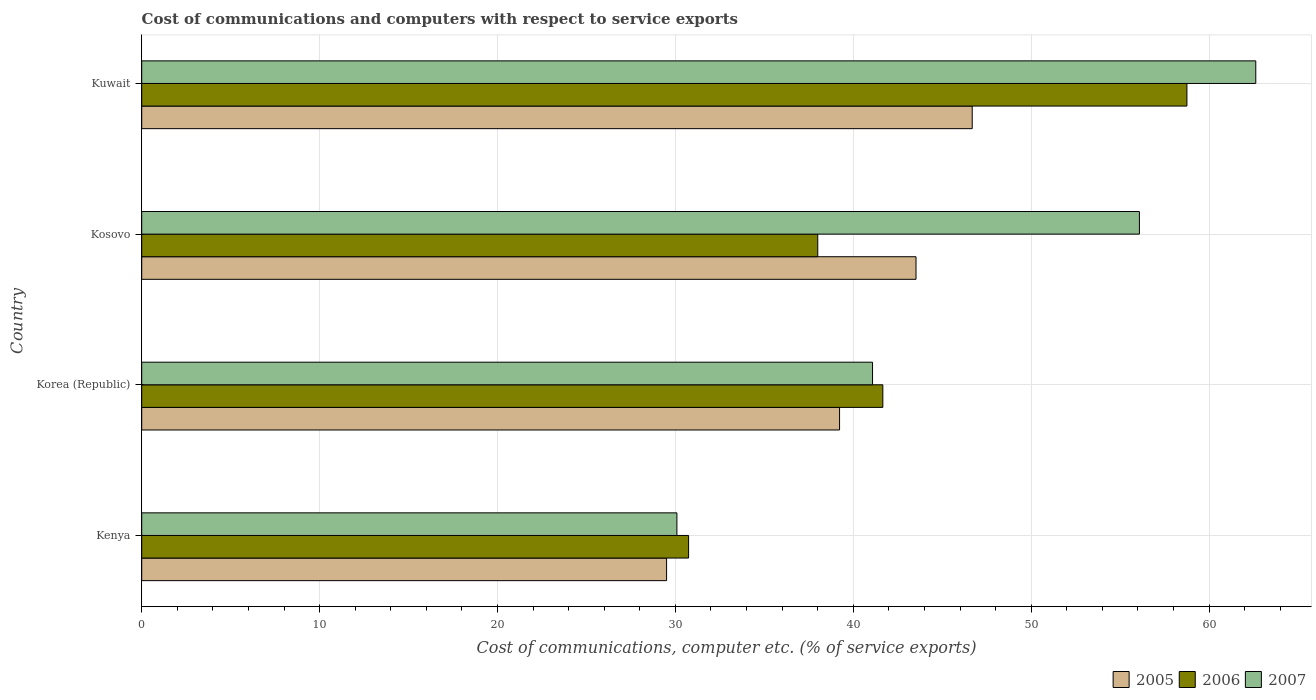How many different coloured bars are there?
Your answer should be very brief. 3. What is the label of the 4th group of bars from the top?
Offer a very short reply. Kenya. In how many cases, is the number of bars for a given country not equal to the number of legend labels?
Make the answer very short. 0. What is the cost of communications and computers in 2007 in Korea (Republic)?
Your answer should be very brief. 41.08. Across all countries, what is the maximum cost of communications and computers in 2005?
Make the answer very short. 46.69. Across all countries, what is the minimum cost of communications and computers in 2006?
Make the answer very short. 30.74. In which country was the cost of communications and computers in 2006 maximum?
Your response must be concise. Kuwait. In which country was the cost of communications and computers in 2005 minimum?
Your response must be concise. Kenya. What is the total cost of communications and computers in 2005 in the graph?
Give a very brief answer. 158.95. What is the difference between the cost of communications and computers in 2006 in Kenya and that in Kosovo?
Offer a terse response. -7.26. What is the difference between the cost of communications and computers in 2006 in Kosovo and the cost of communications and computers in 2007 in Korea (Republic)?
Provide a short and direct response. -3.08. What is the average cost of communications and computers in 2007 per country?
Your response must be concise. 47.47. What is the difference between the cost of communications and computers in 2006 and cost of communications and computers in 2005 in Korea (Republic)?
Ensure brevity in your answer.  2.43. What is the ratio of the cost of communications and computers in 2005 in Korea (Republic) to that in Kosovo?
Offer a very short reply. 0.9. What is the difference between the highest and the second highest cost of communications and computers in 2006?
Offer a terse response. 17.09. What is the difference between the highest and the lowest cost of communications and computers in 2006?
Your response must be concise. 28.01. In how many countries, is the cost of communications and computers in 2007 greater than the average cost of communications and computers in 2007 taken over all countries?
Your response must be concise. 2. Is the sum of the cost of communications and computers in 2005 in Kenya and Kosovo greater than the maximum cost of communications and computers in 2007 across all countries?
Make the answer very short. Yes. What does the 3rd bar from the bottom in Kenya represents?
Ensure brevity in your answer.  2007. How many bars are there?
Make the answer very short. 12. How many countries are there in the graph?
Keep it short and to the point. 4. Does the graph contain grids?
Provide a succinct answer. Yes. How are the legend labels stacked?
Make the answer very short. Horizontal. What is the title of the graph?
Your response must be concise. Cost of communications and computers with respect to service exports. Does "1995" appear as one of the legend labels in the graph?
Keep it short and to the point. No. What is the label or title of the X-axis?
Give a very brief answer. Cost of communications, computer etc. (% of service exports). What is the Cost of communications, computer etc. (% of service exports) of 2005 in Kenya?
Offer a very short reply. 29.5. What is the Cost of communications, computer etc. (% of service exports) in 2006 in Kenya?
Your response must be concise. 30.74. What is the Cost of communications, computer etc. (% of service exports) of 2007 in Kenya?
Provide a short and direct response. 30.09. What is the Cost of communications, computer etc. (% of service exports) of 2005 in Korea (Republic)?
Make the answer very short. 39.23. What is the Cost of communications, computer etc. (% of service exports) in 2006 in Korea (Republic)?
Your answer should be very brief. 41.66. What is the Cost of communications, computer etc. (% of service exports) in 2007 in Korea (Republic)?
Your answer should be compact. 41.08. What is the Cost of communications, computer etc. (% of service exports) in 2005 in Kosovo?
Offer a very short reply. 43.53. What is the Cost of communications, computer etc. (% of service exports) of 2006 in Kosovo?
Provide a short and direct response. 38. What is the Cost of communications, computer etc. (% of service exports) of 2007 in Kosovo?
Provide a succinct answer. 56.09. What is the Cost of communications, computer etc. (% of service exports) in 2005 in Kuwait?
Your answer should be compact. 46.69. What is the Cost of communications, computer etc. (% of service exports) in 2006 in Kuwait?
Give a very brief answer. 58.76. What is the Cost of communications, computer etc. (% of service exports) in 2007 in Kuwait?
Your answer should be compact. 62.63. Across all countries, what is the maximum Cost of communications, computer etc. (% of service exports) in 2005?
Ensure brevity in your answer.  46.69. Across all countries, what is the maximum Cost of communications, computer etc. (% of service exports) of 2006?
Provide a short and direct response. 58.76. Across all countries, what is the maximum Cost of communications, computer etc. (% of service exports) in 2007?
Offer a very short reply. 62.63. Across all countries, what is the minimum Cost of communications, computer etc. (% of service exports) of 2005?
Keep it short and to the point. 29.5. Across all countries, what is the minimum Cost of communications, computer etc. (% of service exports) of 2006?
Provide a succinct answer. 30.74. Across all countries, what is the minimum Cost of communications, computer etc. (% of service exports) of 2007?
Offer a terse response. 30.09. What is the total Cost of communications, computer etc. (% of service exports) of 2005 in the graph?
Offer a terse response. 158.95. What is the total Cost of communications, computer etc. (% of service exports) in 2006 in the graph?
Your response must be concise. 169.16. What is the total Cost of communications, computer etc. (% of service exports) of 2007 in the graph?
Your response must be concise. 189.88. What is the difference between the Cost of communications, computer etc. (% of service exports) in 2005 in Kenya and that in Korea (Republic)?
Provide a succinct answer. -9.72. What is the difference between the Cost of communications, computer etc. (% of service exports) in 2006 in Kenya and that in Korea (Republic)?
Offer a very short reply. -10.92. What is the difference between the Cost of communications, computer etc. (% of service exports) of 2007 in Kenya and that in Korea (Republic)?
Give a very brief answer. -11. What is the difference between the Cost of communications, computer etc. (% of service exports) of 2005 in Kenya and that in Kosovo?
Offer a terse response. -14.02. What is the difference between the Cost of communications, computer etc. (% of service exports) in 2006 in Kenya and that in Kosovo?
Keep it short and to the point. -7.26. What is the difference between the Cost of communications, computer etc. (% of service exports) in 2007 in Kenya and that in Kosovo?
Your response must be concise. -26. What is the difference between the Cost of communications, computer etc. (% of service exports) in 2005 in Kenya and that in Kuwait?
Keep it short and to the point. -17.18. What is the difference between the Cost of communications, computer etc. (% of service exports) in 2006 in Kenya and that in Kuwait?
Ensure brevity in your answer.  -28.01. What is the difference between the Cost of communications, computer etc. (% of service exports) in 2007 in Kenya and that in Kuwait?
Provide a succinct answer. -32.54. What is the difference between the Cost of communications, computer etc. (% of service exports) of 2005 in Korea (Republic) and that in Kosovo?
Offer a very short reply. -4.3. What is the difference between the Cost of communications, computer etc. (% of service exports) in 2006 in Korea (Republic) and that in Kosovo?
Your response must be concise. 3.66. What is the difference between the Cost of communications, computer etc. (% of service exports) in 2007 in Korea (Republic) and that in Kosovo?
Offer a very short reply. -15. What is the difference between the Cost of communications, computer etc. (% of service exports) of 2005 in Korea (Republic) and that in Kuwait?
Provide a succinct answer. -7.46. What is the difference between the Cost of communications, computer etc. (% of service exports) of 2006 in Korea (Republic) and that in Kuwait?
Make the answer very short. -17.09. What is the difference between the Cost of communications, computer etc. (% of service exports) of 2007 in Korea (Republic) and that in Kuwait?
Offer a terse response. -21.54. What is the difference between the Cost of communications, computer etc. (% of service exports) in 2005 in Kosovo and that in Kuwait?
Offer a very short reply. -3.16. What is the difference between the Cost of communications, computer etc. (% of service exports) of 2006 in Kosovo and that in Kuwait?
Offer a very short reply. -20.75. What is the difference between the Cost of communications, computer etc. (% of service exports) in 2007 in Kosovo and that in Kuwait?
Your answer should be very brief. -6.54. What is the difference between the Cost of communications, computer etc. (% of service exports) in 2005 in Kenya and the Cost of communications, computer etc. (% of service exports) in 2006 in Korea (Republic)?
Your answer should be compact. -12.16. What is the difference between the Cost of communications, computer etc. (% of service exports) of 2005 in Kenya and the Cost of communications, computer etc. (% of service exports) of 2007 in Korea (Republic)?
Offer a terse response. -11.58. What is the difference between the Cost of communications, computer etc. (% of service exports) of 2006 in Kenya and the Cost of communications, computer etc. (% of service exports) of 2007 in Korea (Republic)?
Keep it short and to the point. -10.34. What is the difference between the Cost of communications, computer etc. (% of service exports) of 2005 in Kenya and the Cost of communications, computer etc. (% of service exports) of 2006 in Kosovo?
Provide a short and direct response. -8.5. What is the difference between the Cost of communications, computer etc. (% of service exports) of 2005 in Kenya and the Cost of communications, computer etc. (% of service exports) of 2007 in Kosovo?
Make the answer very short. -26.58. What is the difference between the Cost of communications, computer etc. (% of service exports) in 2006 in Kenya and the Cost of communications, computer etc. (% of service exports) in 2007 in Kosovo?
Keep it short and to the point. -25.34. What is the difference between the Cost of communications, computer etc. (% of service exports) in 2005 in Kenya and the Cost of communications, computer etc. (% of service exports) in 2006 in Kuwait?
Provide a short and direct response. -29.25. What is the difference between the Cost of communications, computer etc. (% of service exports) of 2005 in Kenya and the Cost of communications, computer etc. (% of service exports) of 2007 in Kuwait?
Provide a succinct answer. -33.12. What is the difference between the Cost of communications, computer etc. (% of service exports) of 2006 in Kenya and the Cost of communications, computer etc. (% of service exports) of 2007 in Kuwait?
Your answer should be compact. -31.88. What is the difference between the Cost of communications, computer etc. (% of service exports) in 2005 in Korea (Republic) and the Cost of communications, computer etc. (% of service exports) in 2006 in Kosovo?
Your answer should be compact. 1.23. What is the difference between the Cost of communications, computer etc. (% of service exports) in 2005 in Korea (Republic) and the Cost of communications, computer etc. (% of service exports) in 2007 in Kosovo?
Your answer should be very brief. -16.86. What is the difference between the Cost of communications, computer etc. (% of service exports) of 2006 in Korea (Republic) and the Cost of communications, computer etc. (% of service exports) of 2007 in Kosovo?
Offer a terse response. -14.42. What is the difference between the Cost of communications, computer etc. (% of service exports) in 2005 in Korea (Republic) and the Cost of communications, computer etc. (% of service exports) in 2006 in Kuwait?
Make the answer very short. -19.53. What is the difference between the Cost of communications, computer etc. (% of service exports) in 2005 in Korea (Republic) and the Cost of communications, computer etc. (% of service exports) in 2007 in Kuwait?
Your answer should be very brief. -23.4. What is the difference between the Cost of communications, computer etc. (% of service exports) in 2006 in Korea (Republic) and the Cost of communications, computer etc. (% of service exports) in 2007 in Kuwait?
Make the answer very short. -20.96. What is the difference between the Cost of communications, computer etc. (% of service exports) of 2005 in Kosovo and the Cost of communications, computer etc. (% of service exports) of 2006 in Kuwait?
Keep it short and to the point. -15.23. What is the difference between the Cost of communications, computer etc. (% of service exports) of 2005 in Kosovo and the Cost of communications, computer etc. (% of service exports) of 2007 in Kuwait?
Give a very brief answer. -19.1. What is the difference between the Cost of communications, computer etc. (% of service exports) of 2006 in Kosovo and the Cost of communications, computer etc. (% of service exports) of 2007 in Kuwait?
Your answer should be compact. -24.62. What is the average Cost of communications, computer etc. (% of service exports) in 2005 per country?
Provide a short and direct response. 39.74. What is the average Cost of communications, computer etc. (% of service exports) of 2006 per country?
Your answer should be very brief. 42.29. What is the average Cost of communications, computer etc. (% of service exports) of 2007 per country?
Provide a succinct answer. 47.47. What is the difference between the Cost of communications, computer etc. (% of service exports) of 2005 and Cost of communications, computer etc. (% of service exports) of 2006 in Kenya?
Offer a terse response. -1.24. What is the difference between the Cost of communications, computer etc. (% of service exports) of 2005 and Cost of communications, computer etc. (% of service exports) of 2007 in Kenya?
Provide a succinct answer. -0.58. What is the difference between the Cost of communications, computer etc. (% of service exports) of 2006 and Cost of communications, computer etc. (% of service exports) of 2007 in Kenya?
Offer a very short reply. 0.66. What is the difference between the Cost of communications, computer etc. (% of service exports) in 2005 and Cost of communications, computer etc. (% of service exports) in 2006 in Korea (Republic)?
Ensure brevity in your answer.  -2.43. What is the difference between the Cost of communications, computer etc. (% of service exports) in 2005 and Cost of communications, computer etc. (% of service exports) in 2007 in Korea (Republic)?
Offer a very short reply. -1.85. What is the difference between the Cost of communications, computer etc. (% of service exports) of 2006 and Cost of communications, computer etc. (% of service exports) of 2007 in Korea (Republic)?
Your answer should be compact. 0.58. What is the difference between the Cost of communications, computer etc. (% of service exports) in 2005 and Cost of communications, computer etc. (% of service exports) in 2006 in Kosovo?
Offer a very short reply. 5.52. What is the difference between the Cost of communications, computer etc. (% of service exports) in 2005 and Cost of communications, computer etc. (% of service exports) in 2007 in Kosovo?
Your response must be concise. -12.56. What is the difference between the Cost of communications, computer etc. (% of service exports) of 2006 and Cost of communications, computer etc. (% of service exports) of 2007 in Kosovo?
Ensure brevity in your answer.  -18.08. What is the difference between the Cost of communications, computer etc. (% of service exports) of 2005 and Cost of communications, computer etc. (% of service exports) of 2006 in Kuwait?
Your answer should be compact. -12.07. What is the difference between the Cost of communications, computer etc. (% of service exports) in 2005 and Cost of communications, computer etc. (% of service exports) in 2007 in Kuwait?
Give a very brief answer. -15.94. What is the difference between the Cost of communications, computer etc. (% of service exports) in 2006 and Cost of communications, computer etc. (% of service exports) in 2007 in Kuwait?
Provide a succinct answer. -3.87. What is the ratio of the Cost of communications, computer etc. (% of service exports) in 2005 in Kenya to that in Korea (Republic)?
Provide a succinct answer. 0.75. What is the ratio of the Cost of communications, computer etc. (% of service exports) of 2006 in Kenya to that in Korea (Republic)?
Provide a succinct answer. 0.74. What is the ratio of the Cost of communications, computer etc. (% of service exports) in 2007 in Kenya to that in Korea (Republic)?
Ensure brevity in your answer.  0.73. What is the ratio of the Cost of communications, computer etc. (% of service exports) in 2005 in Kenya to that in Kosovo?
Offer a very short reply. 0.68. What is the ratio of the Cost of communications, computer etc. (% of service exports) in 2006 in Kenya to that in Kosovo?
Give a very brief answer. 0.81. What is the ratio of the Cost of communications, computer etc. (% of service exports) of 2007 in Kenya to that in Kosovo?
Keep it short and to the point. 0.54. What is the ratio of the Cost of communications, computer etc. (% of service exports) of 2005 in Kenya to that in Kuwait?
Your response must be concise. 0.63. What is the ratio of the Cost of communications, computer etc. (% of service exports) of 2006 in Kenya to that in Kuwait?
Your answer should be compact. 0.52. What is the ratio of the Cost of communications, computer etc. (% of service exports) in 2007 in Kenya to that in Kuwait?
Offer a very short reply. 0.48. What is the ratio of the Cost of communications, computer etc. (% of service exports) of 2005 in Korea (Republic) to that in Kosovo?
Provide a short and direct response. 0.9. What is the ratio of the Cost of communications, computer etc. (% of service exports) in 2006 in Korea (Republic) to that in Kosovo?
Keep it short and to the point. 1.1. What is the ratio of the Cost of communications, computer etc. (% of service exports) in 2007 in Korea (Republic) to that in Kosovo?
Offer a very short reply. 0.73. What is the ratio of the Cost of communications, computer etc. (% of service exports) of 2005 in Korea (Republic) to that in Kuwait?
Ensure brevity in your answer.  0.84. What is the ratio of the Cost of communications, computer etc. (% of service exports) of 2006 in Korea (Republic) to that in Kuwait?
Offer a terse response. 0.71. What is the ratio of the Cost of communications, computer etc. (% of service exports) of 2007 in Korea (Republic) to that in Kuwait?
Ensure brevity in your answer.  0.66. What is the ratio of the Cost of communications, computer etc. (% of service exports) of 2005 in Kosovo to that in Kuwait?
Make the answer very short. 0.93. What is the ratio of the Cost of communications, computer etc. (% of service exports) in 2006 in Kosovo to that in Kuwait?
Your answer should be very brief. 0.65. What is the ratio of the Cost of communications, computer etc. (% of service exports) of 2007 in Kosovo to that in Kuwait?
Your response must be concise. 0.9. What is the difference between the highest and the second highest Cost of communications, computer etc. (% of service exports) of 2005?
Your answer should be compact. 3.16. What is the difference between the highest and the second highest Cost of communications, computer etc. (% of service exports) in 2006?
Your answer should be very brief. 17.09. What is the difference between the highest and the second highest Cost of communications, computer etc. (% of service exports) of 2007?
Offer a terse response. 6.54. What is the difference between the highest and the lowest Cost of communications, computer etc. (% of service exports) of 2005?
Ensure brevity in your answer.  17.18. What is the difference between the highest and the lowest Cost of communications, computer etc. (% of service exports) in 2006?
Provide a succinct answer. 28.01. What is the difference between the highest and the lowest Cost of communications, computer etc. (% of service exports) of 2007?
Your answer should be very brief. 32.54. 